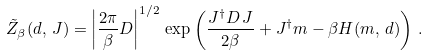<formula> <loc_0><loc_0><loc_500><loc_500>\tilde { Z } _ { \beta } ( d , \, J ) = \left | \frac { 2 \pi } { \beta } D \right | ^ { 1 / 2 } \, \exp \left ( { \frac { J ^ { \dagger } D \, J } { 2 \beta } + J ^ { \dagger } m - \beta H ( m , \, d ) } \right ) \, .</formula> 